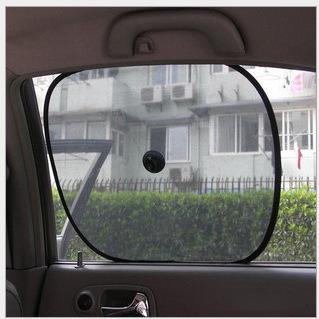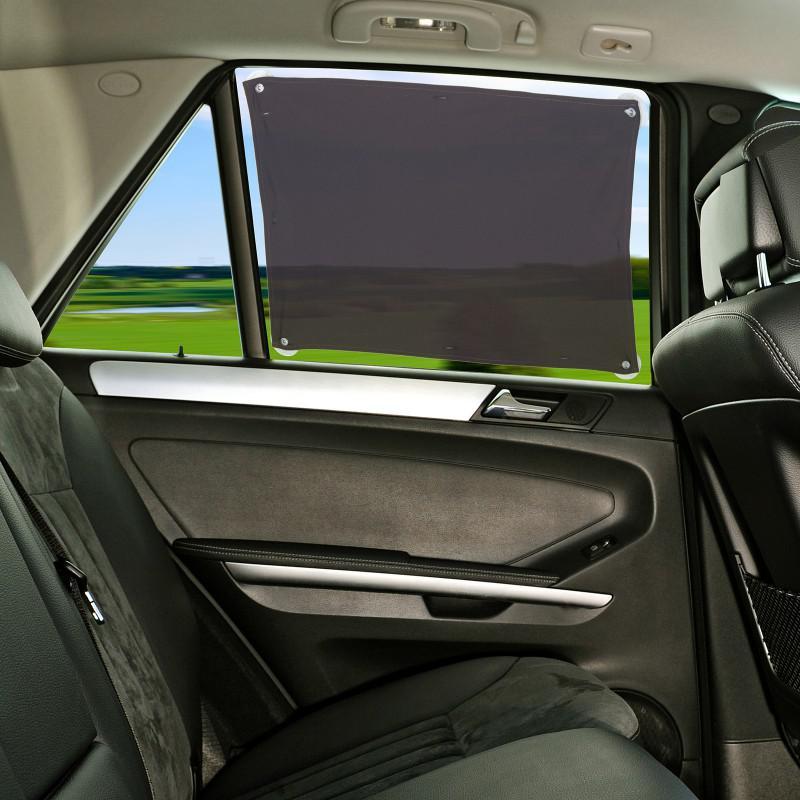The first image is the image on the left, the second image is the image on the right. For the images shown, is this caption "An image shows a car window fitted with a squarish gray shade with nonrounded corners." true? Answer yes or no. Yes. 